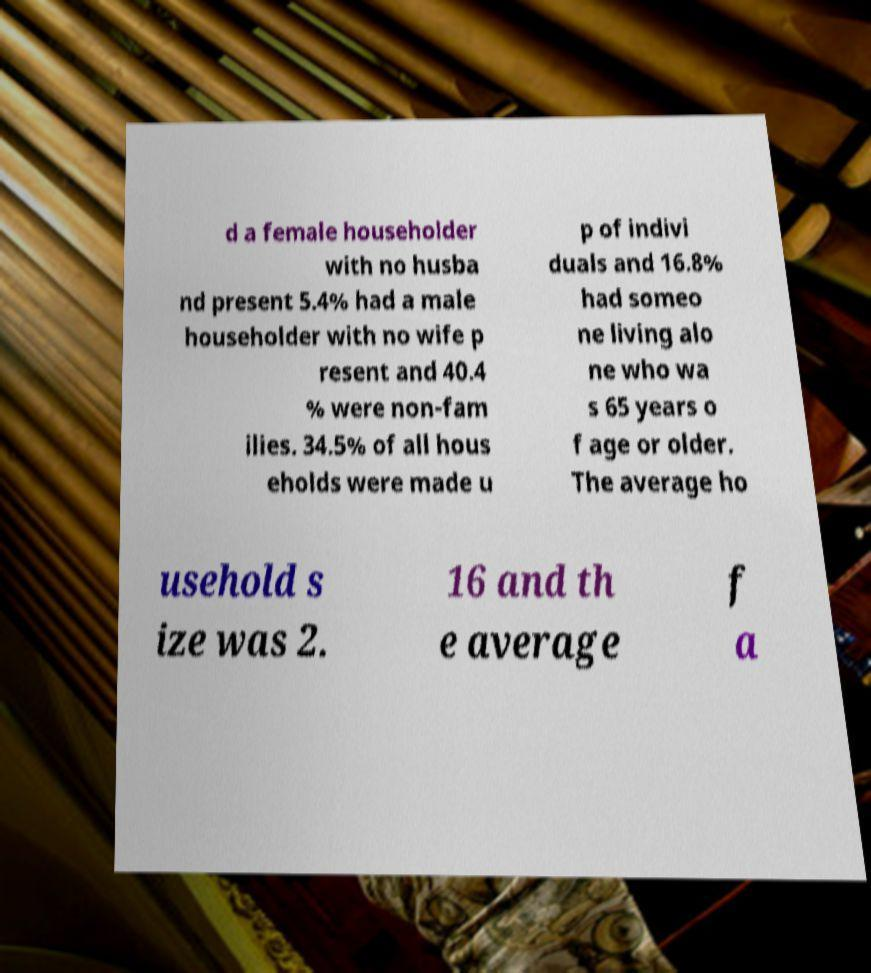For documentation purposes, I need the text within this image transcribed. Could you provide that? d a female householder with no husba nd present 5.4% had a male householder with no wife p resent and 40.4 % were non-fam ilies. 34.5% of all hous eholds were made u p of indivi duals and 16.8% had someo ne living alo ne who wa s 65 years o f age or older. The average ho usehold s ize was 2. 16 and th e average f a 